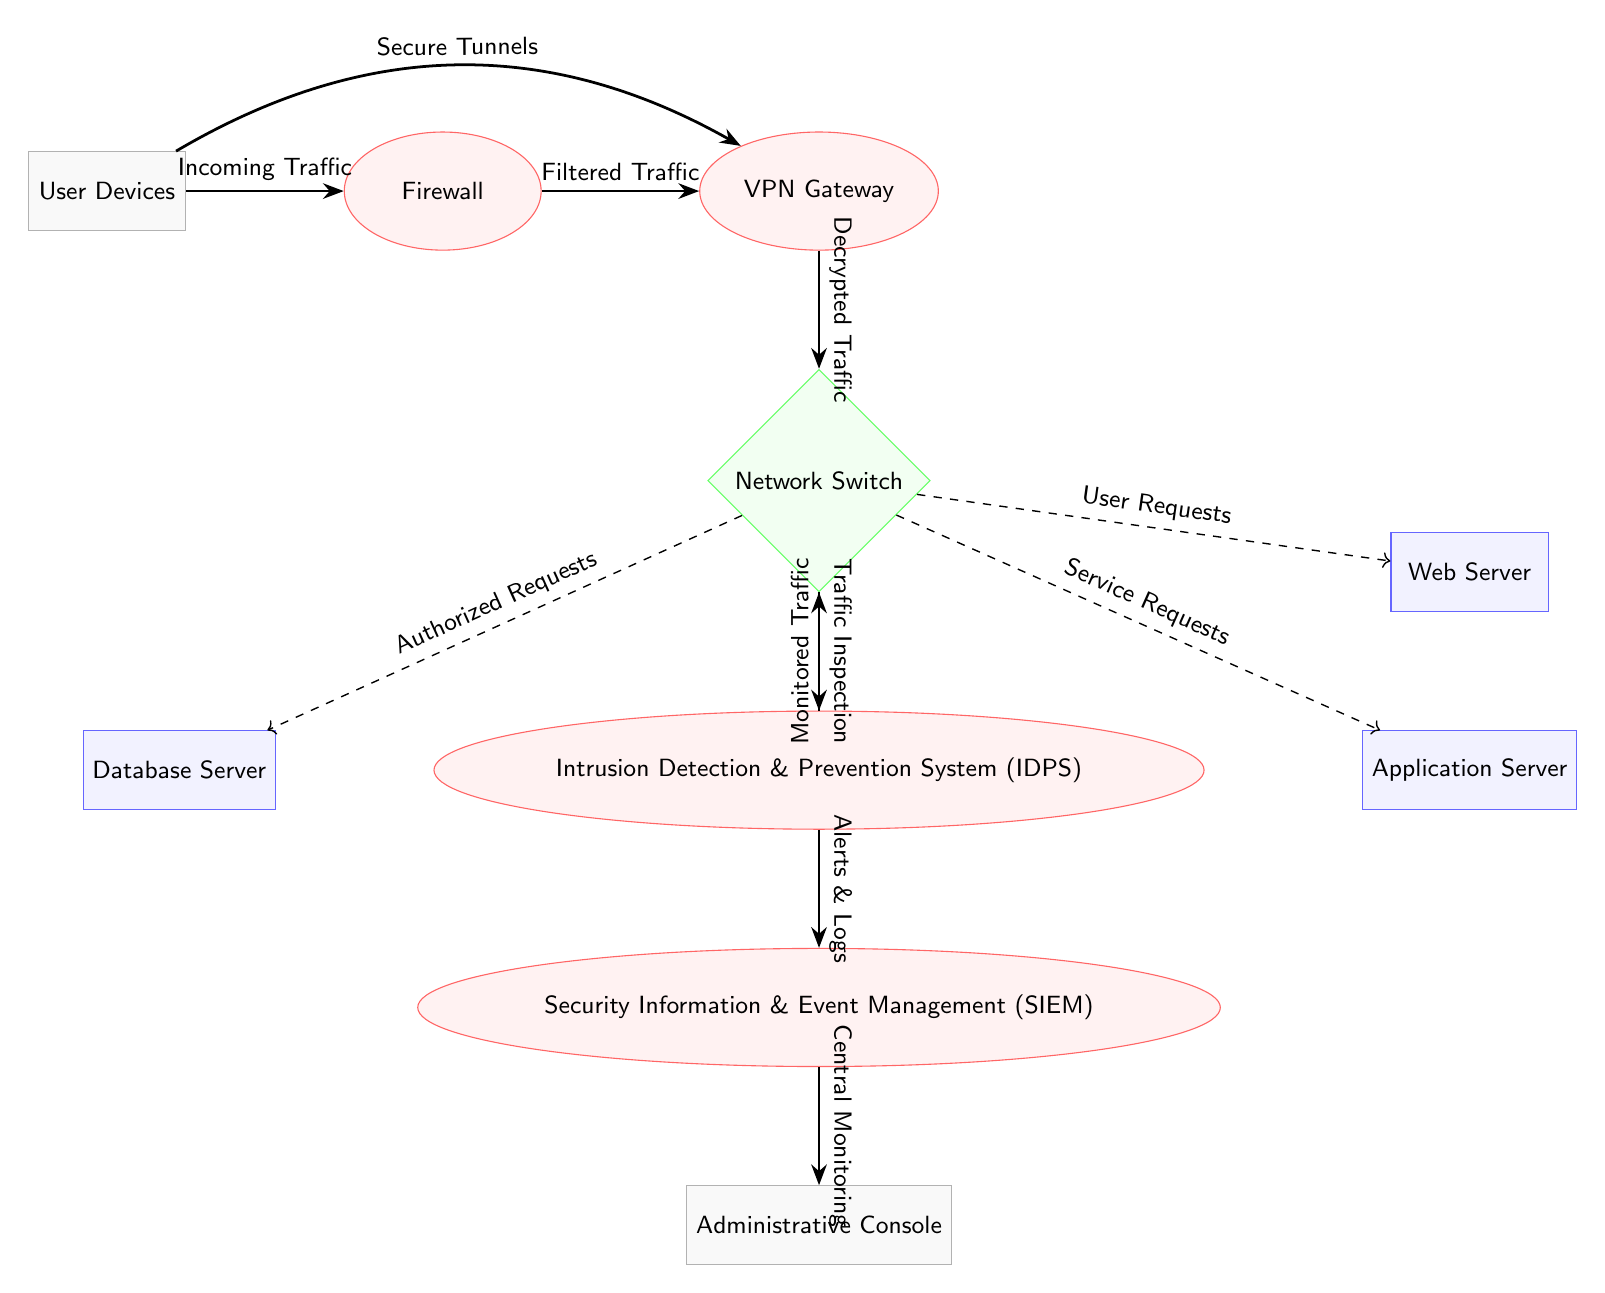What is the first node in the data flow? The diagram shows that the first node in the data flow is "User Devices," as it is positioned at the far left and represents the entry point for incoming traffic.
Answer: User Devices How many total servers are depicted in the diagram? By counting the nodes categorized as servers, which include the Database Server, Application Server, and Web Server, we find a total of three servers in the diagram.
Answer: 3 What type of security component is the "IDPS"? The "IDPS" is categorized as an "Intrusion Detection & Prevention System," which is clearly labeled and depicted as a security component in the diagram.
Answer: security What type of traffic flows from the "IDPS" to the "SIEM"? The diagram indicates that "Alerts & Logs" flow from the "IDPS" to the "SIEM," which highlights the information being passed for monitoring.
Answer: Alerts & Logs What does the "VPN Gateway" use to secure traffic from "User Devices"? The diagram shows that the "VPN Gateway" uses "Secure Tunnels" to secure the traffic coming from "User Devices," which is presented as a labeled arrow connecting the two nodes.
Answer: Secure Tunnels Which node does the "Network Switch" send "Authorized Requests" to? According to the diagram, the "Network Switch" sends "Authorized Requests" to the "Database Server," as indicated by the arrow pointing from the switch to the database.
Answer: Database Server What direction does the traffic flow between the "Application Server" and "Network Switch"? The diagram illustrates that the traffic flows both ways, indicated by "Service Requests" going from the switch to the application server, but it's a unidirectional arrow in this depiction.
Answer: From Network Switch to Application Server How are "User Requests" processed in the network structure? "User Requests" are sent from the "Network Switch" to the "Web Server," indicating a pathway for the requests to be handled accordingly within the network.
Answer: To Web Server What is the role of the "Administrative Console" in the network? The "Administrative Console" is identified as the component receiving "Central Monitoring" from the "SIEM," which emphasizes its role in monitoring the security events.
Answer: Central Monitoring 